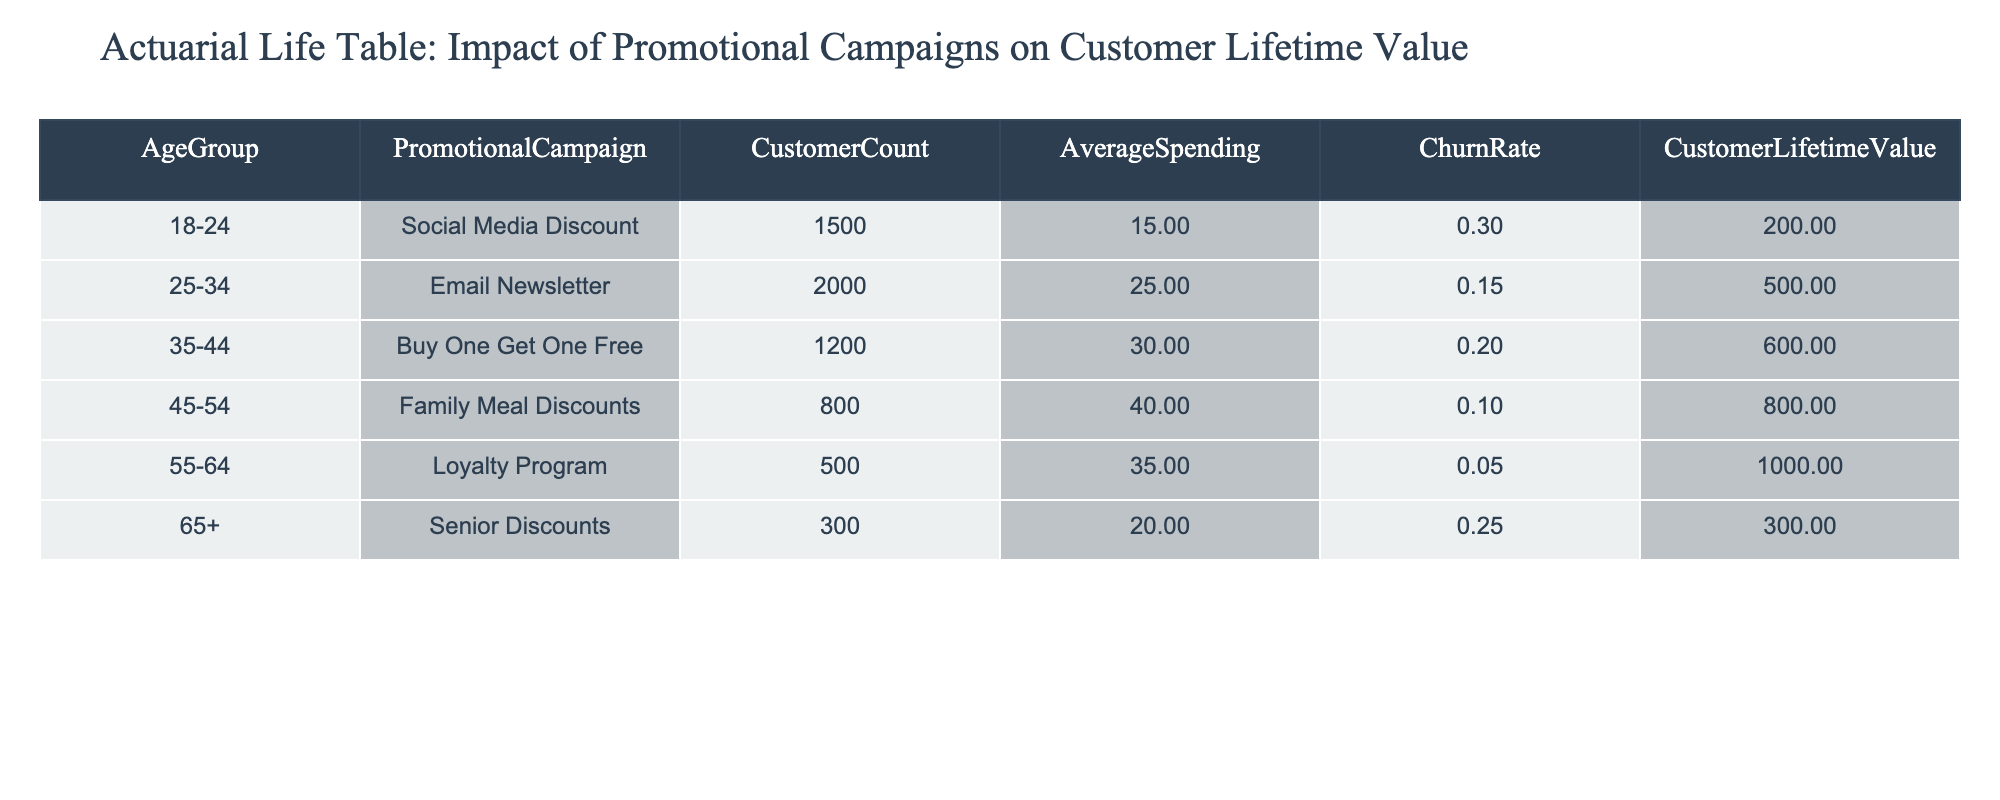What is the Customer Lifetime Value for customers aged 45-54 under the Family Meal Discounts campaign? The table indicates that the Customer Lifetime Value for the age group 45-54 with the Family Meal Discounts campaign is listed in the respective column. Looking at the table, the value is 800.
Answer: 800 What is the Churn Rate for the age group 25-34 participating in the Email Newsletter promotion? The Churn Rate for the age group 25-34 is displayed directly in the table under the corresponding promotional campaign, which shows a value of 0.15.
Answer: 0.15 Which promotional campaign has the highest average spending? To answer this, we need to compare the Average Spending column across all promotional campaigns: Social Media Discount (15.00), Email Newsletter (25.00), Buy One Get One Free (30.00), Family Meal Discounts (40.00), Loyalty Program (35.00), and Senior Discounts (20.00). The highest value is 40.00 under Family Meal Discounts.
Answer: Family Meal Discounts What is the total Customer Lifetime Value for all campaigns targeted at age groups 55-64 and 65+? We add the Customer Lifetime Value from the relevant rows: Age group 55-64 (Loyalty Program) has a value of 1000, and age group 65+ (Senior Discounts) has a value of 300. Summing these gives 1000 + 300 = 1300.
Answer: 1300 Is the Churn Rate for the Loyalty Program lower than that for the Buy One Get One Free campaign? Inspecting the table, the Churn Rate for the Loyalty Program (age group 55-64) is 0.05, while the Churn Rate for Buy One Get One Free (age group 35-44) is 0.20. Since 0.05 is less than 0.20, the statement is true.
Answer: Yes Which age group sees the Customer Lifetime Value decrease as the promotional campaign progresses from Social Media Discount to Senior Discounts? We examine the Customer Lifetime Value across the different age groups: 200.00 (18-24, Social Media Discount) to 300.00 (65+, Senior Discounts). The value decreases from 200.00 to 300.00 indicated that not all promotional campaigns have a decreasing Customer Lifetime Value with age. However, comparing these specific age groups individually, it appears the values do not consistently decrease, thus making it a mixed result based on the age group; but as an overview, the overall Customer Lifetime Value does decrease when looking at the campaigns.
Answer: No What is the average spending across all age groups participating in promotional campaigns? We find the average spending by adding all Average Spending values: 15.00 + 25.00 + 30.00 + 40.00 + 35.00 + 20.00 = 165.00. There are 6 age groups, so the average is calculated as 165.00 / 6 = 27.50.
Answer: 27.50 Which campaign has the lowest customer count? By examining the Customer Count column across the campaigns, we see: Social Media Discount (1500), Email Newsletter (2000), Buy One Get One Free (1200), Family Meal Discounts (800), Loyalty Program (500), and Senior Discounts (300). The campaign with the lowest number is Senior Discounts, with a count of 300.
Answer: Senior Discounts 